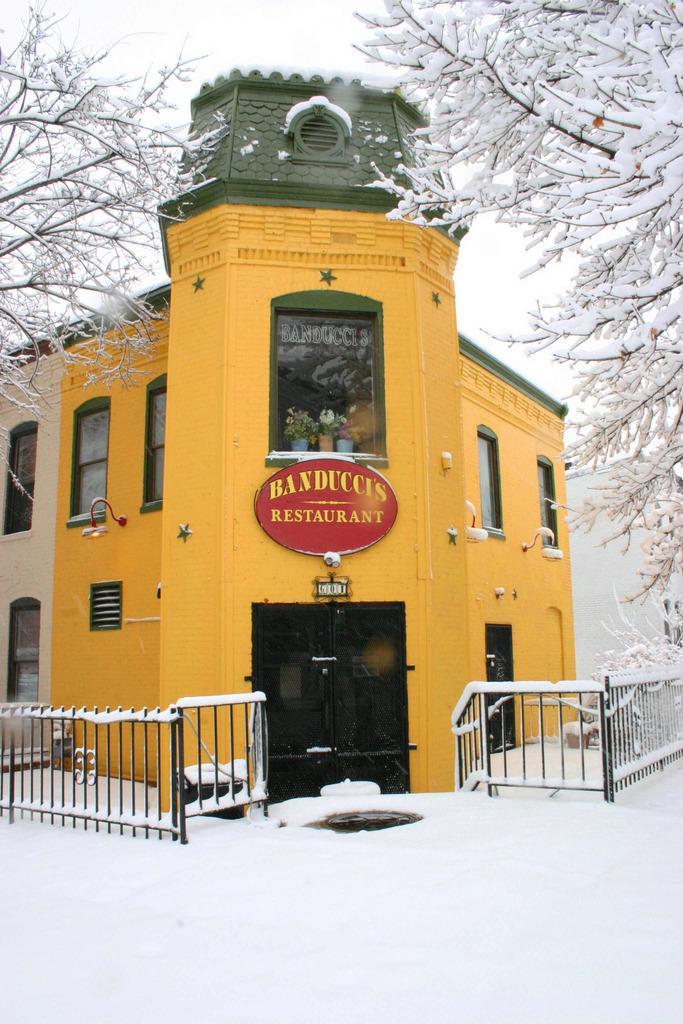Please provide a concise description of this image. This is snow and there is a fence. Here we can see a door, board, windows, building, and trees. In the background there is sky. 